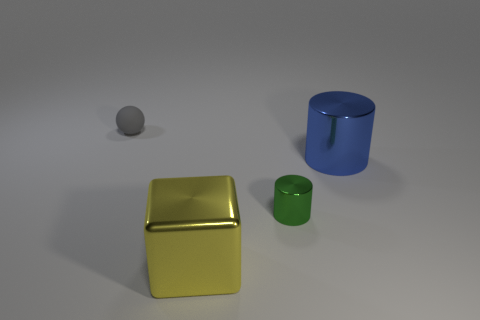Add 2 tiny blue rubber objects. How many objects exist? 6 Subtract all cubes. How many objects are left? 3 Subtract all small cylinders. Subtract all large things. How many objects are left? 1 Add 4 tiny matte objects. How many tiny matte objects are left? 5 Add 3 large gray shiny balls. How many large gray shiny balls exist? 3 Subtract 0 red balls. How many objects are left? 4 